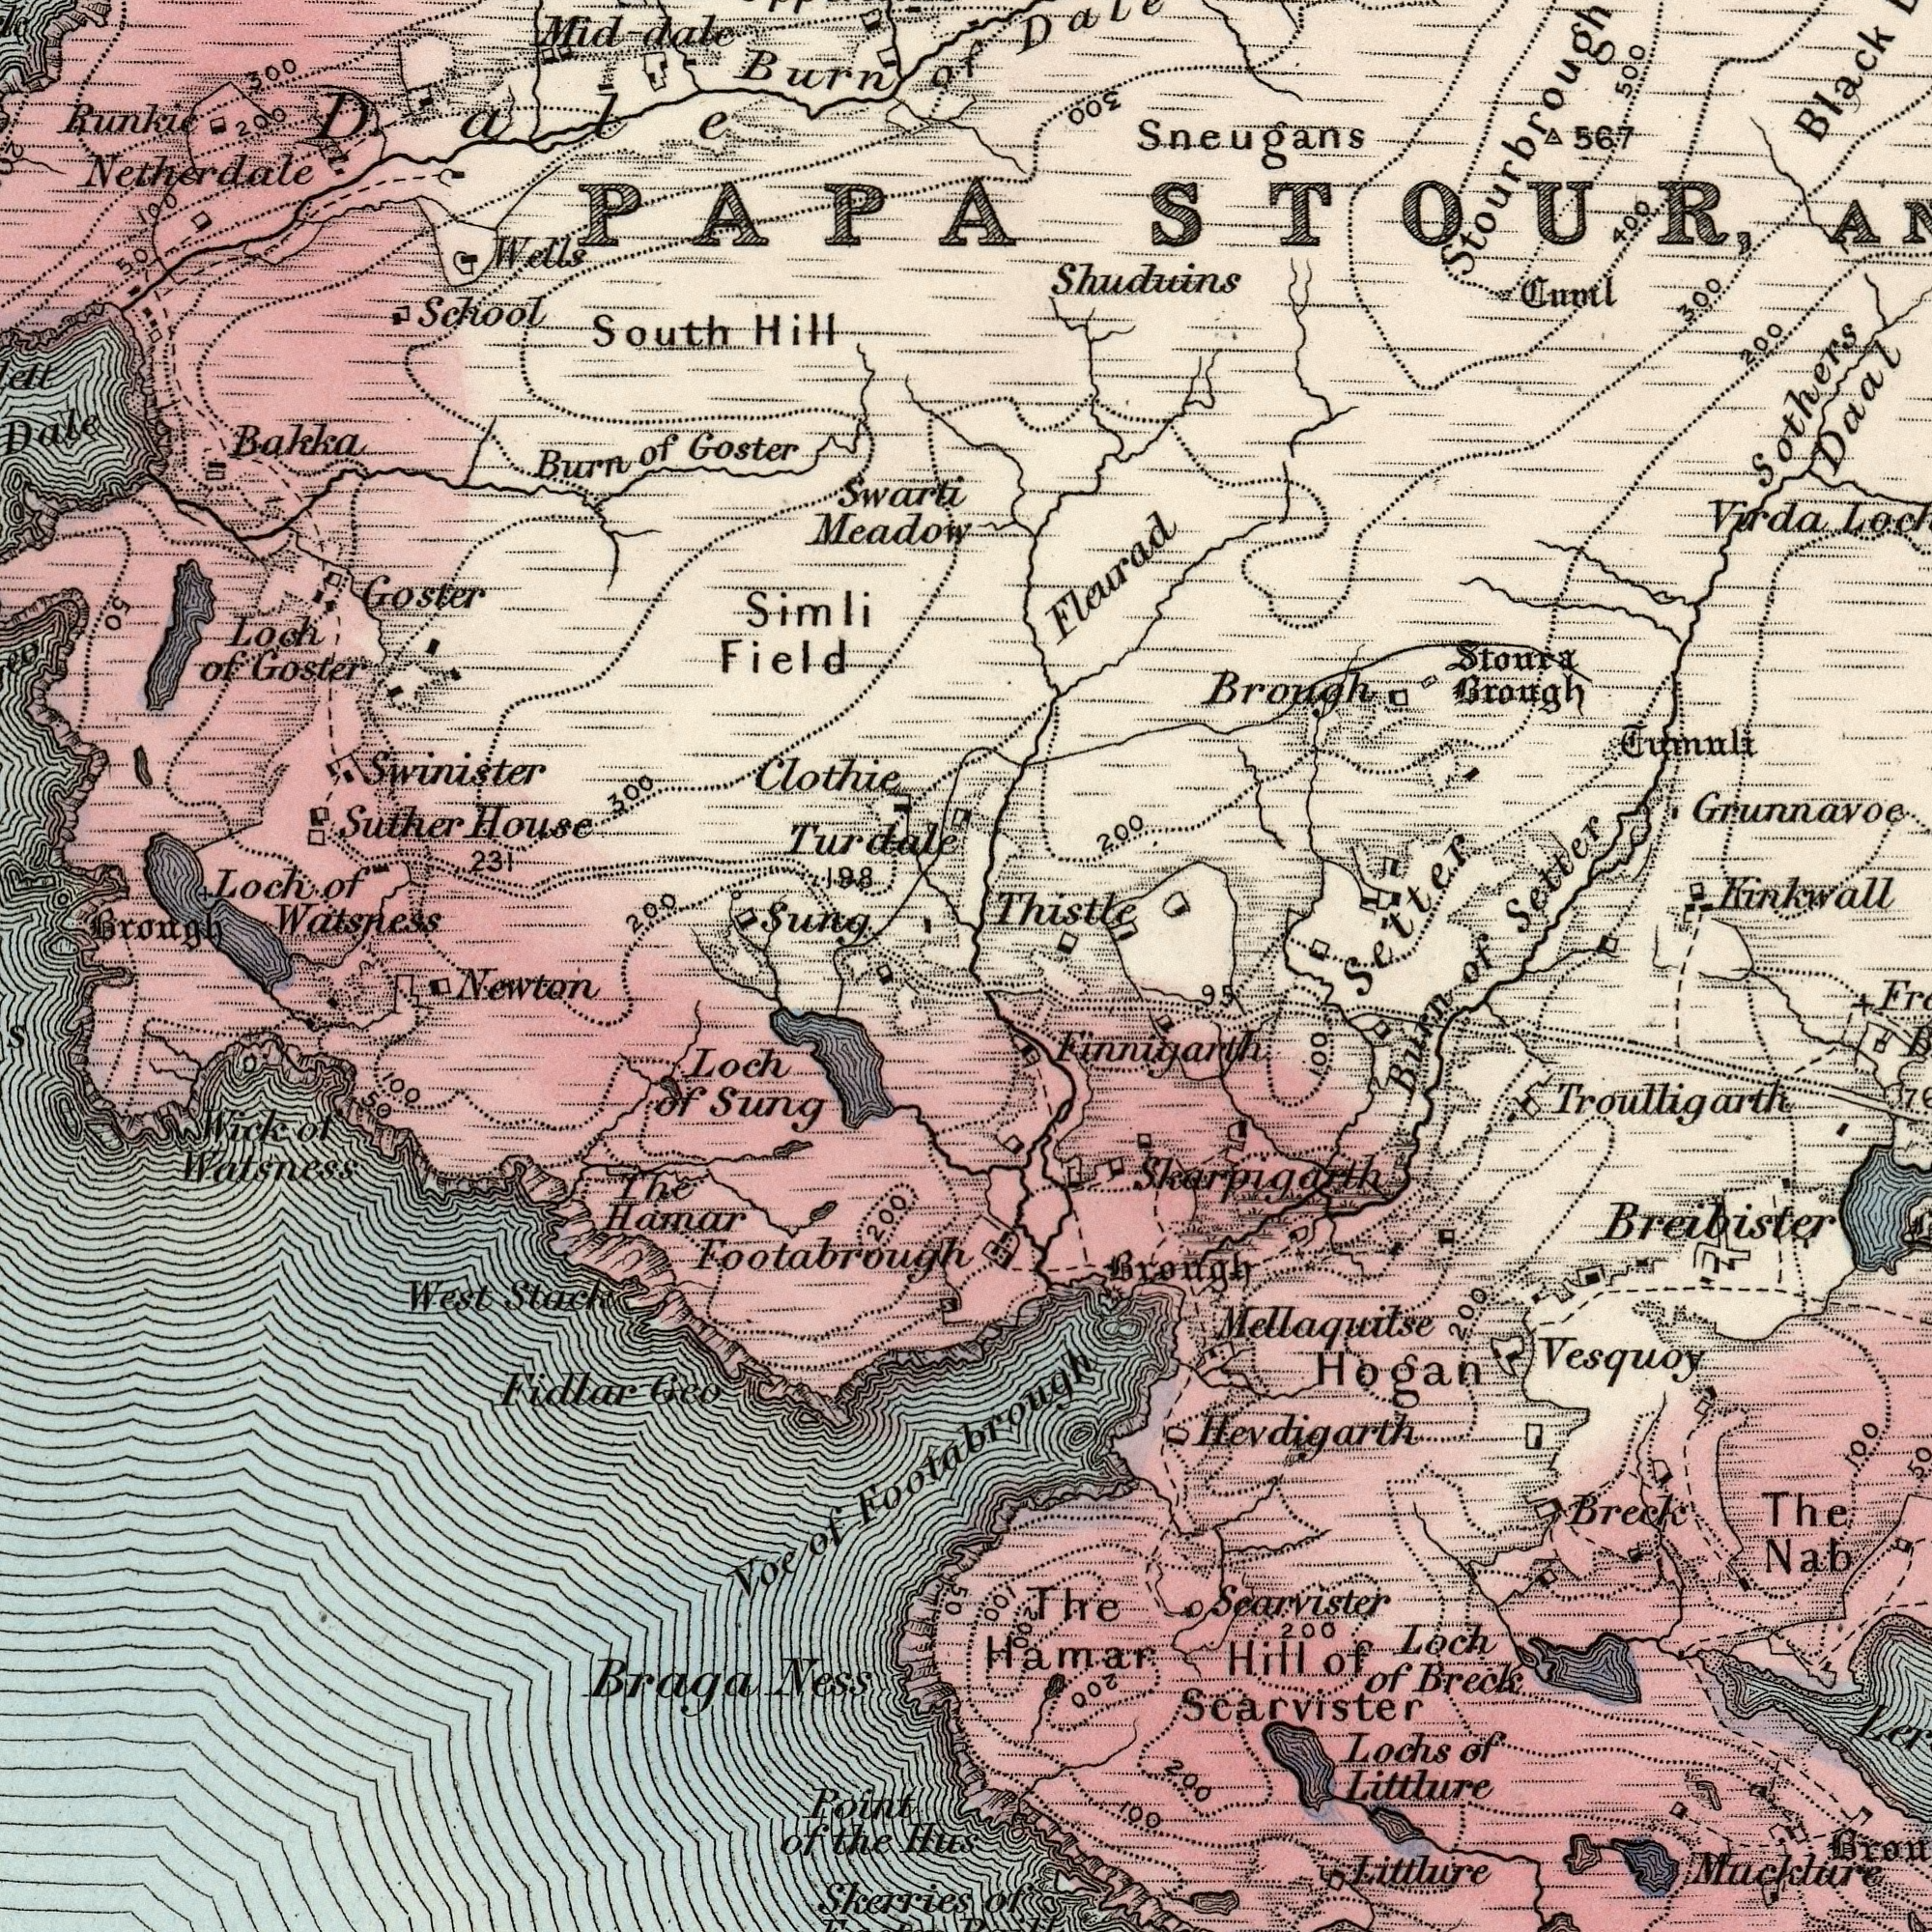What text is shown in the bottom-left quadrant? Hamar Fidlar Ness Loch Point Sung Newton Footabrough Voe West Watsness The Skerries Hus Braga of Stack Geo 200 of of Wick 50 100 Footabrough of the 50 What text appears in the top-left area of the image? Swinister Clothie Watsness Wells School House Swarti South Meadow Suther Field Simli Goster 200 Loch Sung Mid-dale Hill 300 Brongh 300 198 231 of Burn of Runkie Loch of Burn 200 Bakka of Goster 100 Netherdale 50 Turdale Goster Dale PAPA 50 What text is shown in the bottom-right quadrant? Hevdigarth Searvister Littlure Littlure Finnigarth Hamar Breck Loch Vesquoy Breck Scarvister Lochs The Burn Troulligarth Nab Brough 200 Mucklure of The 100 50 Breibister 100 of 200 200 Mellaquilse 100 200 Hogan 200 95 of of 100 Skarpigarth Hill What text can you see in the top-right section? Sneugans Setter Brough Grunnavoe Virda 567 Daal Sothers Black Tumnli Stoura Brough Tuml Kinkwall 200 300 400 Shuduins Fleurad Thistle 200 300 500 Setter STOUR, of 